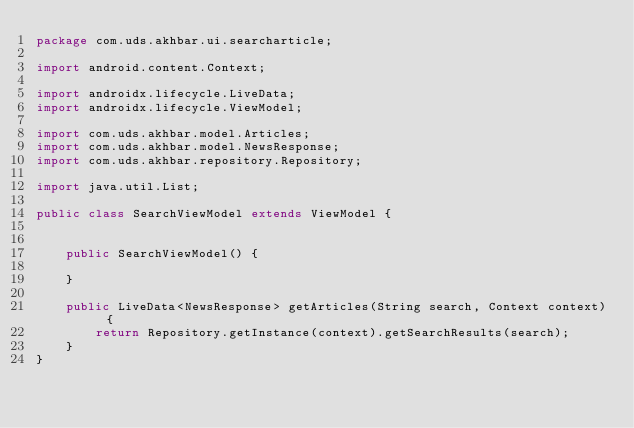Convert code to text. <code><loc_0><loc_0><loc_500><loc_500><_Java_>package com.uds.akhbar.ui.searcharticle;

import android.content.Context;

import androidx.lifecycle.LiveData;
import androidx.lifecycle.ViewModel;

import com.uds.akhbar.model.Articles;
import com.uds.akhbar.model.NewsResponse;
import com.uds.akhbar.repository.Repository;

import java.util.List;

public class SearchViewModel extends ViewModel {


    public SearchViewModel() {

    }

    public LiveData<NewsResponse> getArticles(String search, Context context) {
        return Repository.getInstance(context).getSearchResults(search);
    }
}</code> 